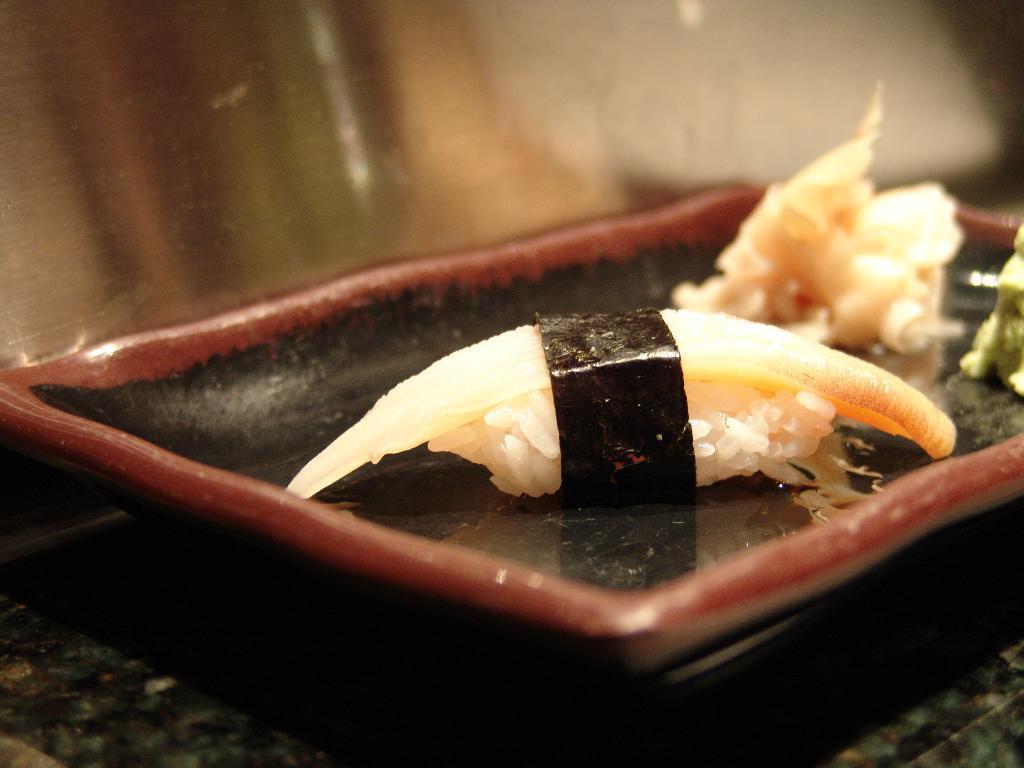Please provide a concise description of this image. In this image there is a plate on the table on which there is so much of food served. 